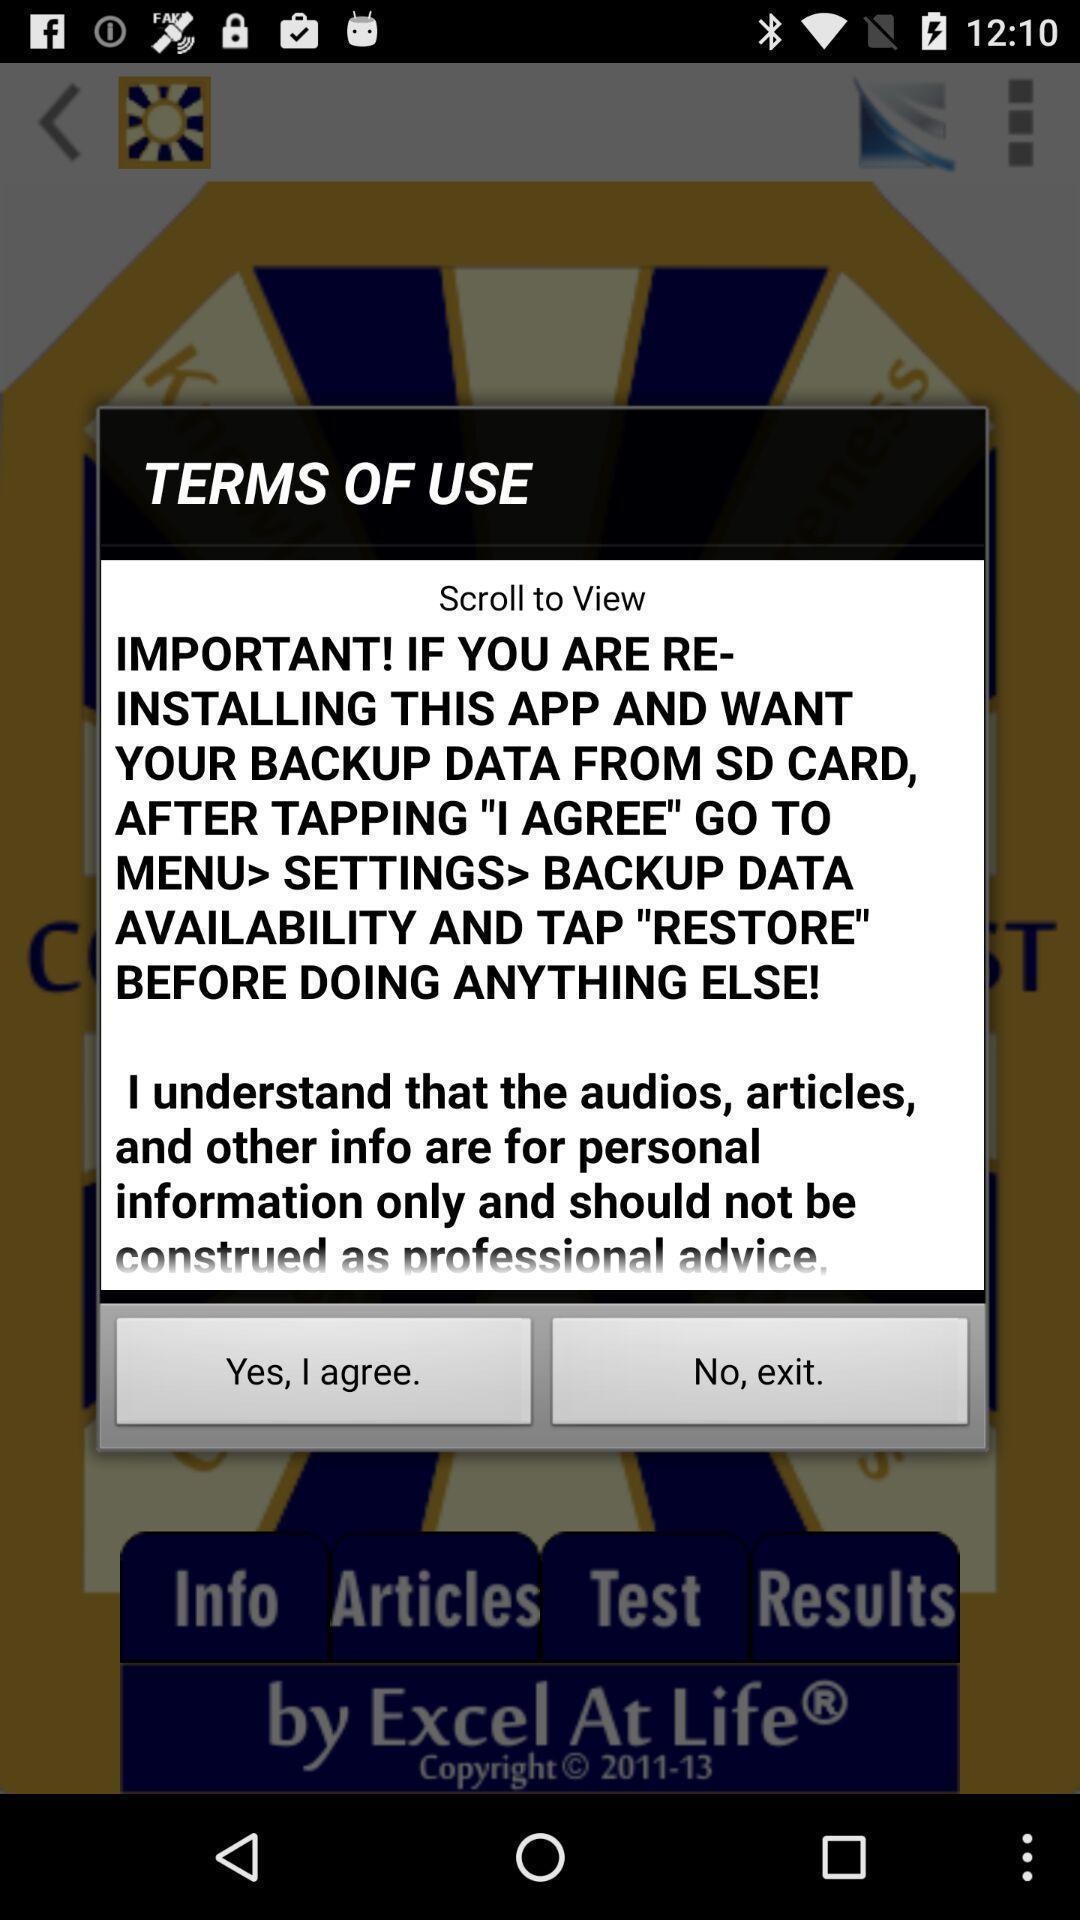Provide a description of this screenshot. Pop-up displaying the terms of use notification. 